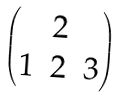<formula> <loc_0><loc_0><loc_500><loc_500>\begin{pmatrix} & 2 & \\ 1 & 2 & 3 \end{pmatrix}</formula> 